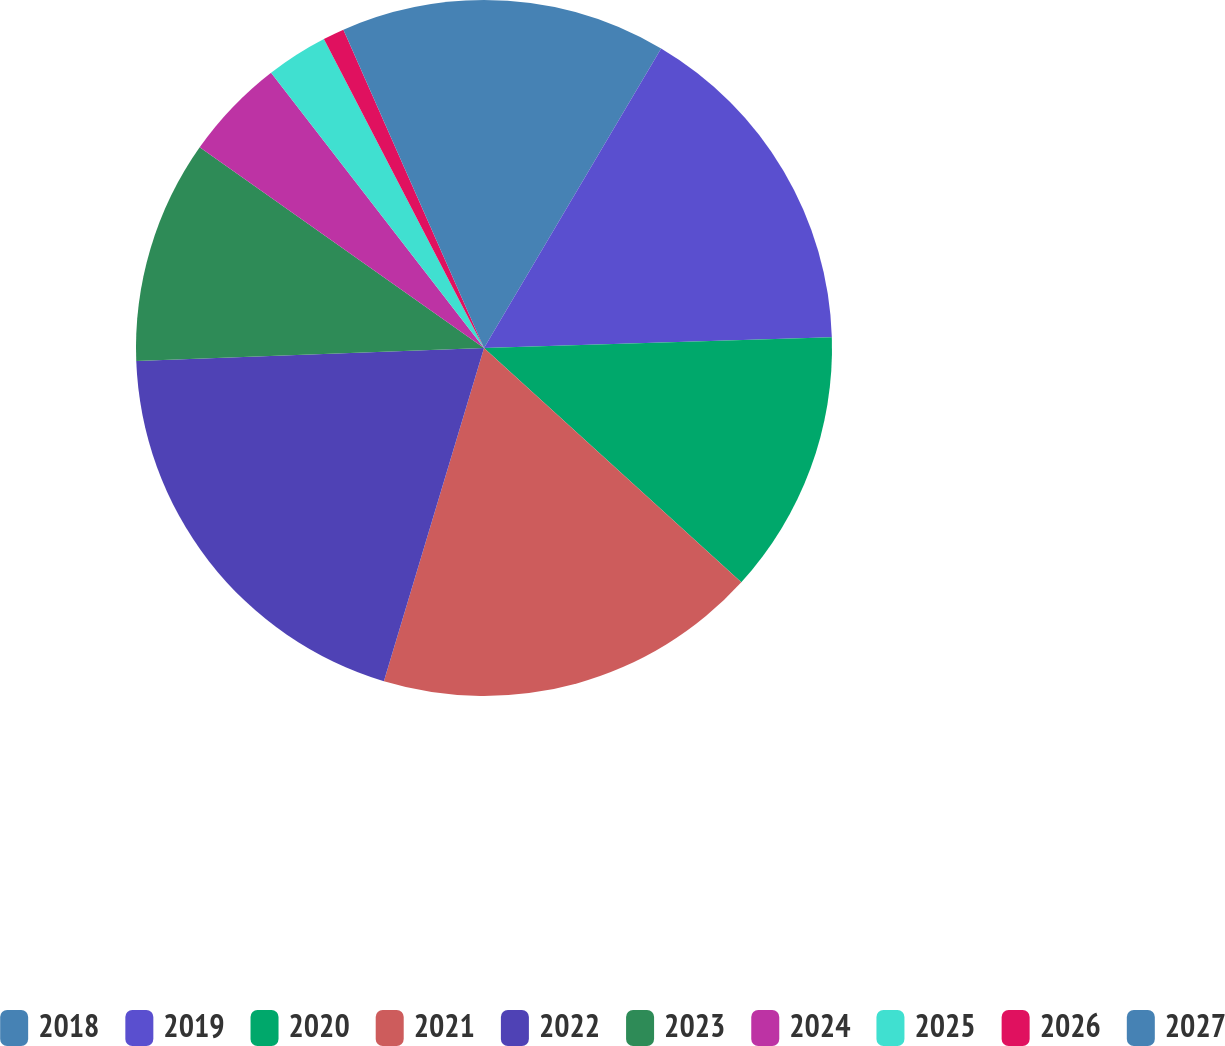Convert chart. <chart><loc_0><loc_0><loc_500><loc_500><pie_chart><fcel>2018<fcel>2019<fcel>2020<fcel>2021<fcel>2022<fcel>2023<fcel>2024<fcel>2025<fcel>2026<fcel>2027<nl><fcel>8.5%<fcel>16.01%<fcel>12.25%<fcel>17.89%<fcel>19.76%<fcel>10.38%<fcel>4.74%<fcel>2.87%<fcel>0.99%<fcel>6.62%<nl></chart> 